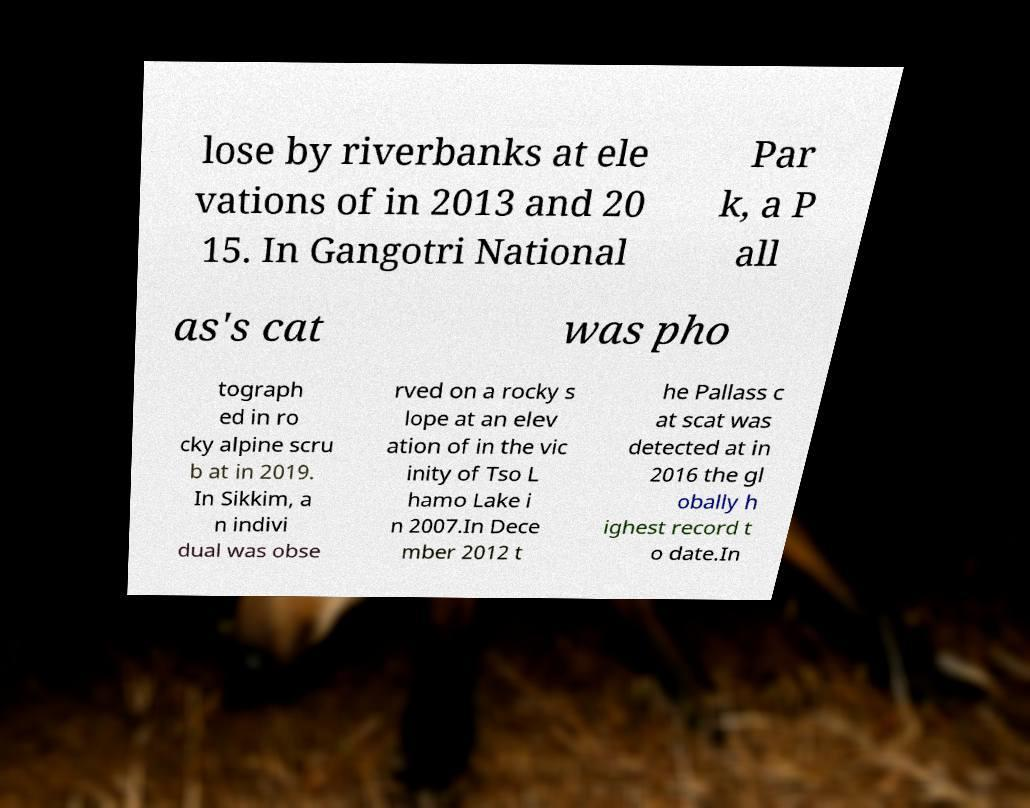What messages or text are displayed in this image? I need them in a readable, typed format. lose by riverbanks at ele vations of in 2013 and 20 15. In Gangotri National Par k, a P all as's cat was pho tograph ed in ro cky alpine scru b at in 2019. In Sikkim, a n indivi dual was obse rved on a rocky s lope at an elev ation of in the vic inity of Tso L hamo Lake i n 2007.In Dece mber 2012 t he Pallass c at scat was detected at in 2016 the gl obally h ighest record t o date.In 